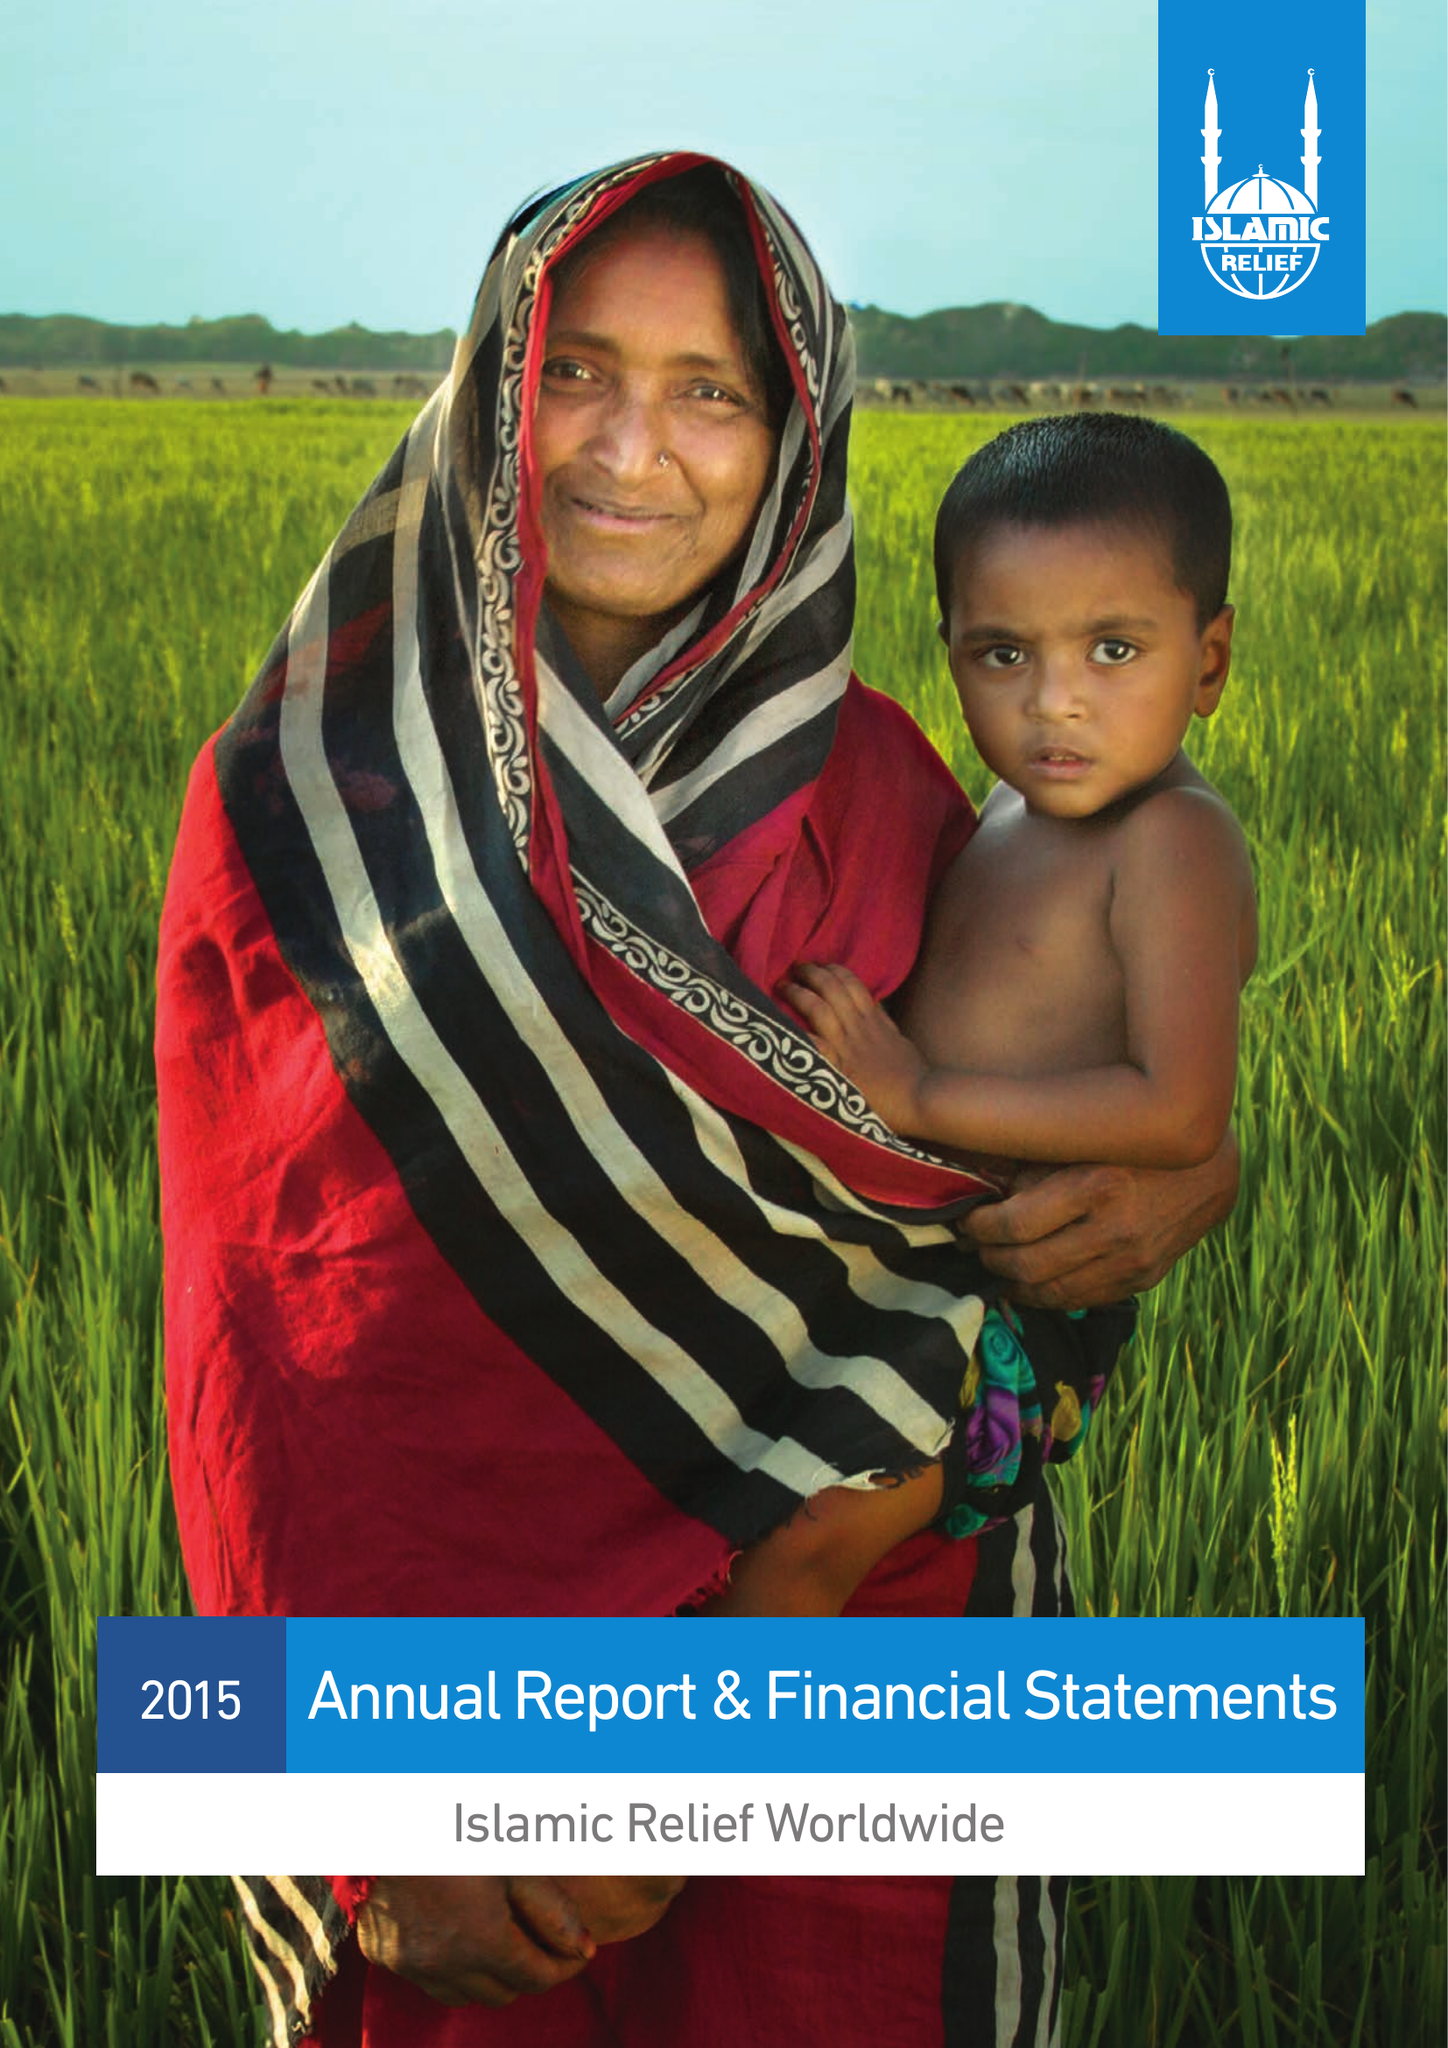What is the value for the income_annually_in_british_pounds?
Answer the question using a single word or phrase. 105576484.00 